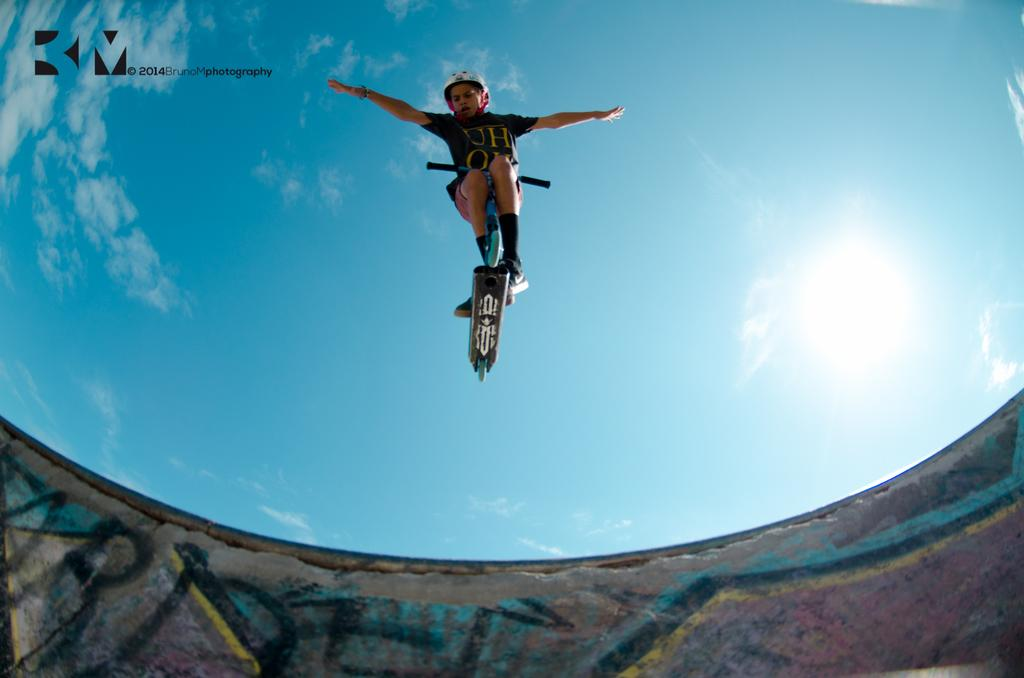What is the main subject of the image? The main subject of the image is a man. What is the man doing in the image? The man is standing on a skateboard. What is the man wearing in the image? The man is wearing a black t-shirt. What can be seen in the background of the image? The sky is visible in the image. What is the shape of the vegetable that the man is holding in the image? There is no vegetable present in the image, and the man is not holding anything. 